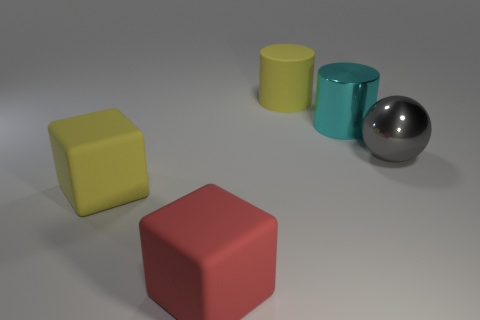Is there any other thing that has the same shape as the gray object?
Keep it short and to the point. No. Is there anything else of the same color as the large metal cylinder?
Your answer should be very brief. No. How many other objects are the same material as the red block?
Provide a short and direct response. 2. What is the size of the cyan shiny object?
Make the answer very short. Large. Are there any large yellow rubber objects of the same shape as the large cyan thing?
Give a very brief answer. Yes. What number of objects are either big gray objects or big rubber objects that are in front of the cyan object?
Your response must be concise. 3. There is a big rubber block on the right side of the yellow matte cube; what color is it?
Provide a short and direct response. Red. There is a yellow cylinder that is to the left of the big gray shiny ball; does it have the same size as the yellow rubber thing in front of the big ball?
Provide a succinct answer. Yes. Are there any gray rubber cubes of the same size as the ball?
Provide a short and direct response. No. What number of big rubber blocks are to the left of the large matte object that is in front of the big yellow rubber cube?
Keep it short and to the point. 1. 